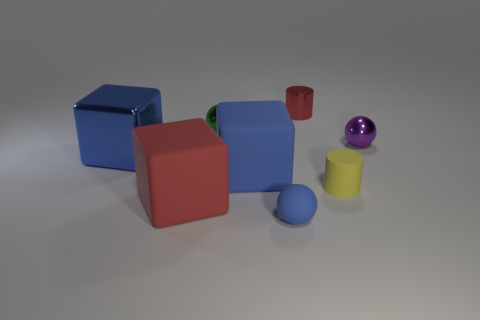There is a red object in front of the big rubber block on the right side of the red object that is in front of the yellow cylinder; what is its shape?
Give a very brief answer. Cube. There is a thing that is on the left side of the small metal cylinder and behind the small purple shiny sphere; what is its size?
Offer a terse response. Small. What number of rubber balls have the same color as the small matte cylinder?
Give a very brief answer. 0. There is a thing that is the same color as the metallic cylinder; what is it made of?
Provide a succinct answer. Rubber. What is the material of the green object?
Your answer should be very brief. Metal. Does the big blue object to the left of the red matte cube have the same material as the small purple thing?
Offer a very short reply. Yes. What shape is the big blue object to the right of the green object?
Ensure brevity in your answer.  Cube. What is the material of the green thing that is the same size as the purple thing?
Provide a short and direct response. Metal. What number of things are rubber things on the left side of the small yellow matte thing or small shiny spheres left of the small purple thing?
Your answer should be very brief. 4. What size is the red object that is the same material as the green thing?
Your response must be concise. Small. 